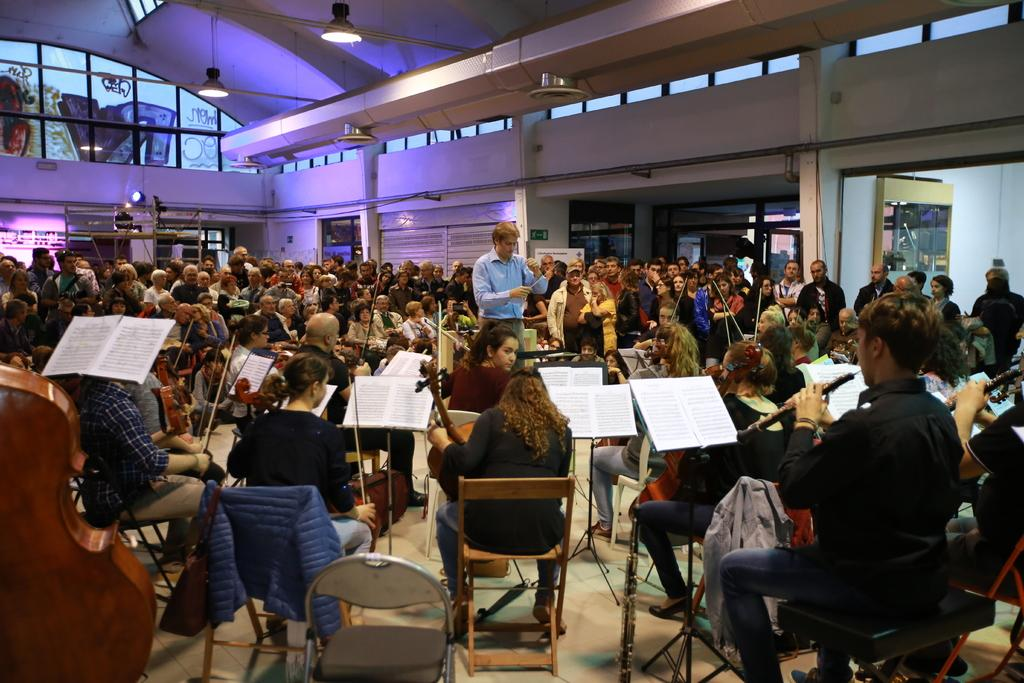How many people are in the image? There is a group of persons in the image. What are the persons in the image doing? The persons are playing musical instruments. Where is the scene taking place? The setting is in a room. How much lunch is visible in the image? There is no lunch present in the image; the persons are playing musical instruments in a room. 